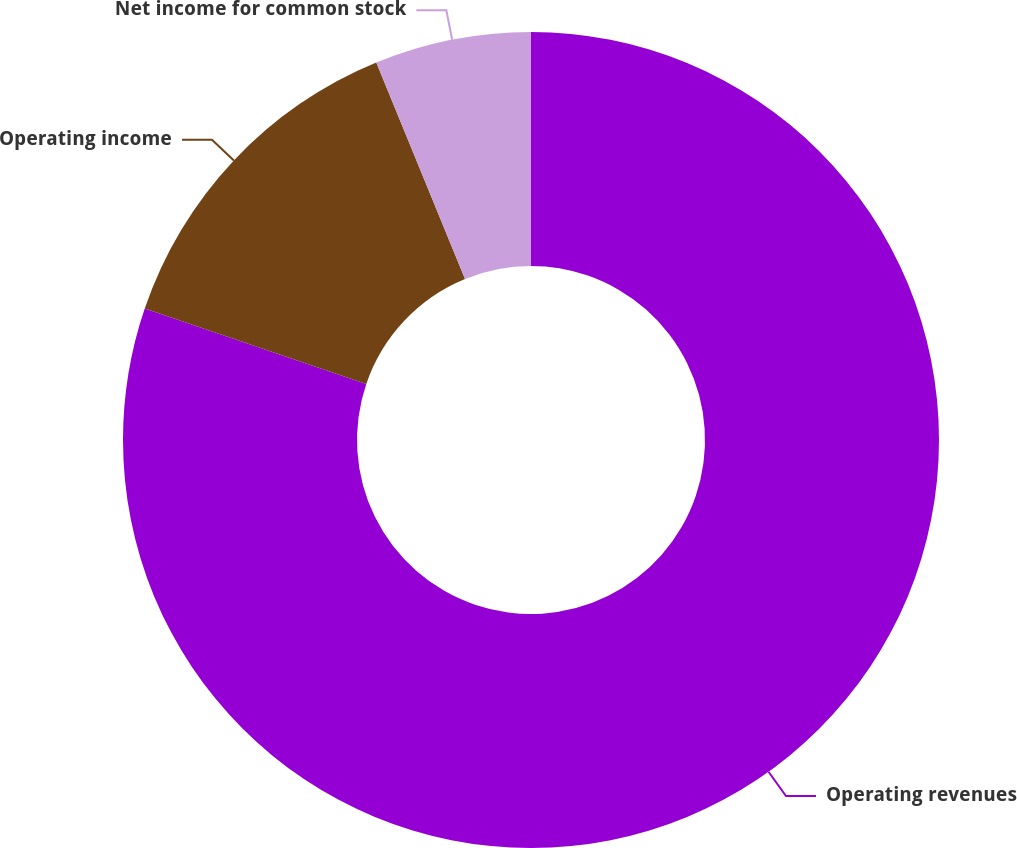Convert chart to OTSL. <chart><loc_0><loc_0><loc_500><loc_500><pie_chart><fcel>Operating revenues<fcel>Operating income<fcel>Net income for common stock<nl><fcel>80.22%<fcel>13.59%<fcel>6.19%<nl></chart> 